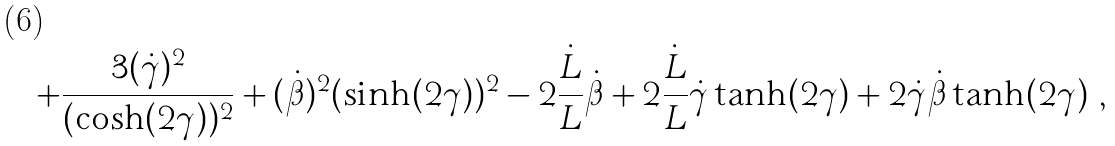Convert formula to latex. <formula><loc_0><loc_0><loc_500><loc_500>+ \frac { 3 ( \dot { \gamma } ) ^ { 2 } } { ( \cosh ( 2 \gamma ) ) ^ { 2 } } + ( \dot { \beta } ) ^ { 2 } ( \sinh ( 2 \gamma ) ) ^ { 2 } - 2 \frac { \dot { L } } { L } \dot { \beta } + 2 \frac { \dot { L } } { L } \dot { \gamma } \tanh ( 2 \gamma ) + 2 \dot { \gamma } \dot { \beta } \tanh ( 2 \gamma ) \ ,</formula> 